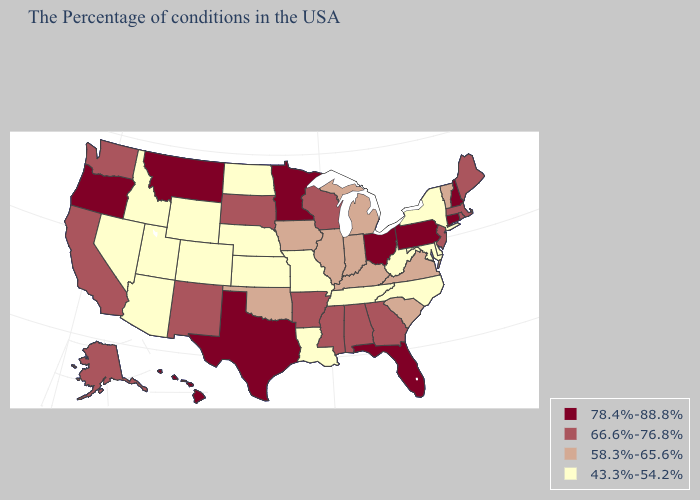Name the states that have a value in the range 58.3%-65.6%?
Keep it brief. Vermont, Virginia, South Carolina, Michigan, Kentucky, Indiana, Illinois, Iowa, Oklahoma. Does South Carolina have the same value as Georgia?
Short answer required. No. What is the lowest value in states that border Delaware?
Concise answer only. 43.3%-54.2%. What is the highest value in states that border Utah?
Short answer required. 66.6%-76.8%. Among the states that border North Carolina , does Georgia have the lowest value?
Be succinct. No. Among the states that border Texas , does Louisiana have the highest value?
Write a very short answer. No. Is the legend a continuous bar?
Keep it brief. No. What is the highest value in states that border Missouri?
Quick response, please. 66.6%-76.8%. What is the value of Hawaii?
Short answer required. 78.4%-88.8%. What is the highest value in the USA?
Be succinct. 78.4%-88.8%. Does Massachusetts have the lowest value in the Northeast?
Short answer required. No. Does Connecticut have the same value as New York?
Keep it brief. No. Does Montana have the same value as Washington?
Be succinct. No. What is the lowest value in states that border Washington?
Short answer required. 43.3%-54.2%. Among the states that border California , does Nevada have the lowest value?
Answer briefly. Yes. 